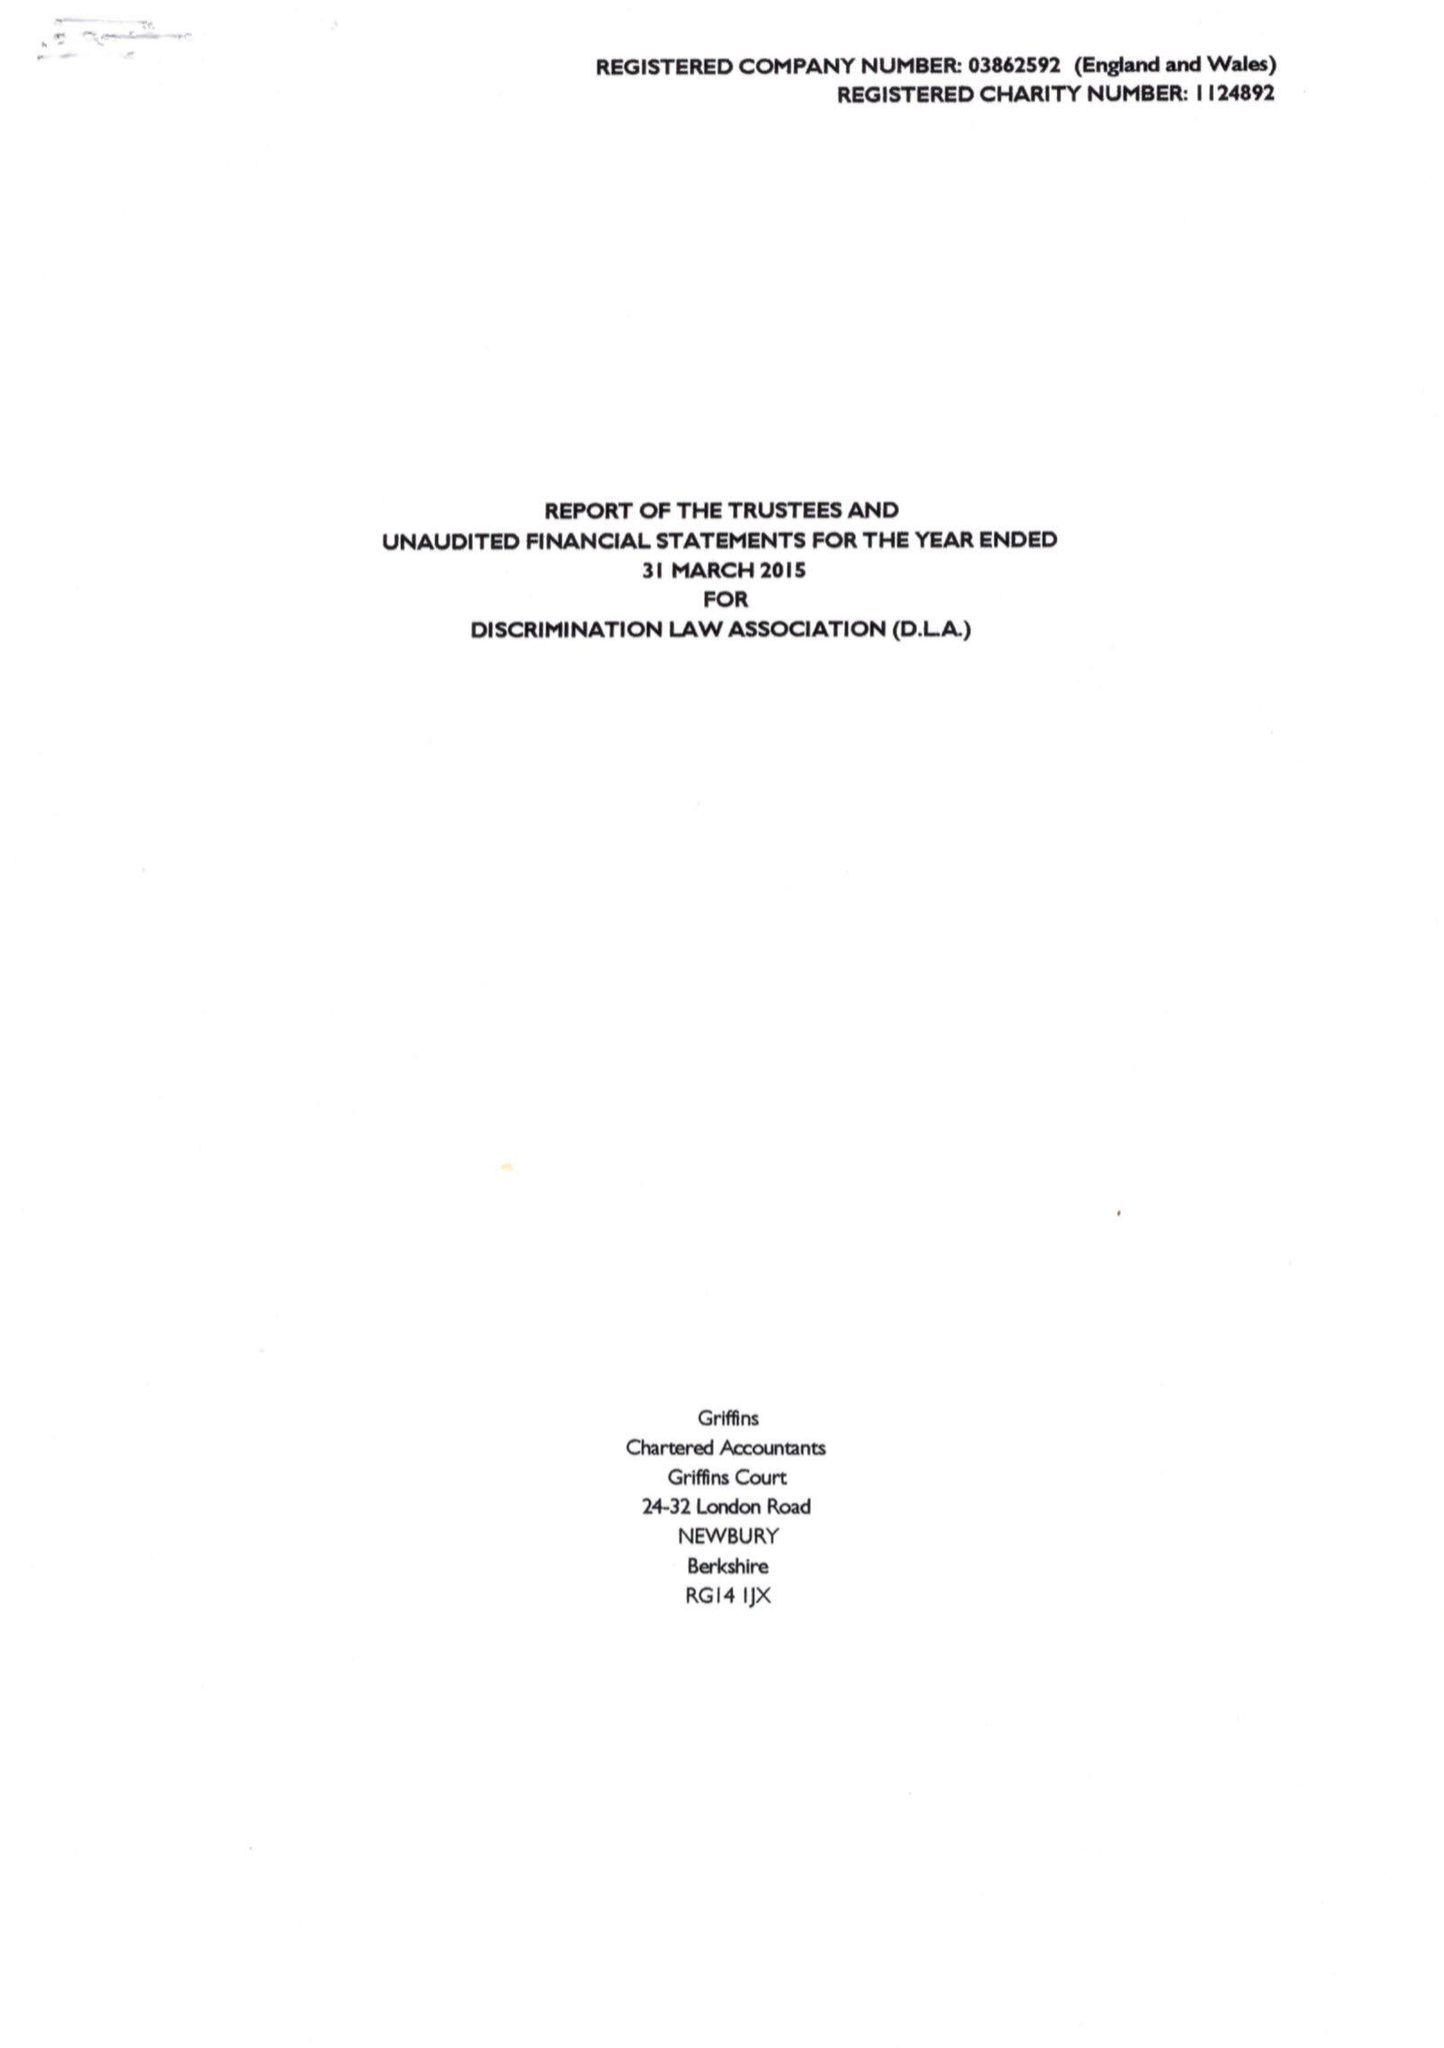What is the value for the spending_annually_in_british_pounds?
Answer the question using a single word or phrase. 31172.00 